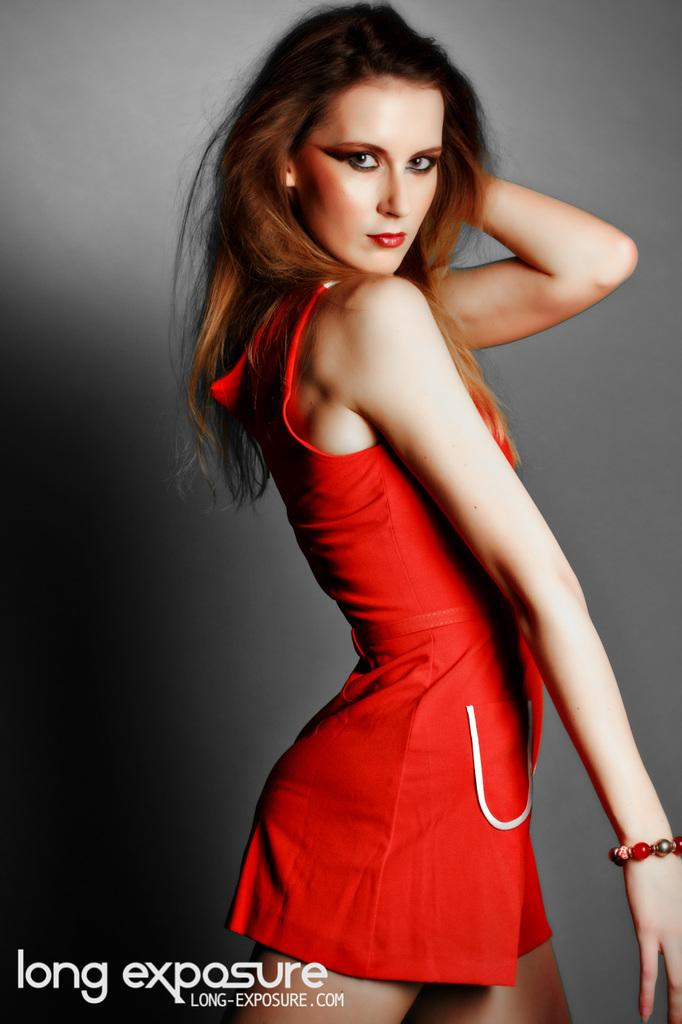<image>
Render a clear and concise summary of the photo. An advertisement for Long Exposure features a model in a red dress. 